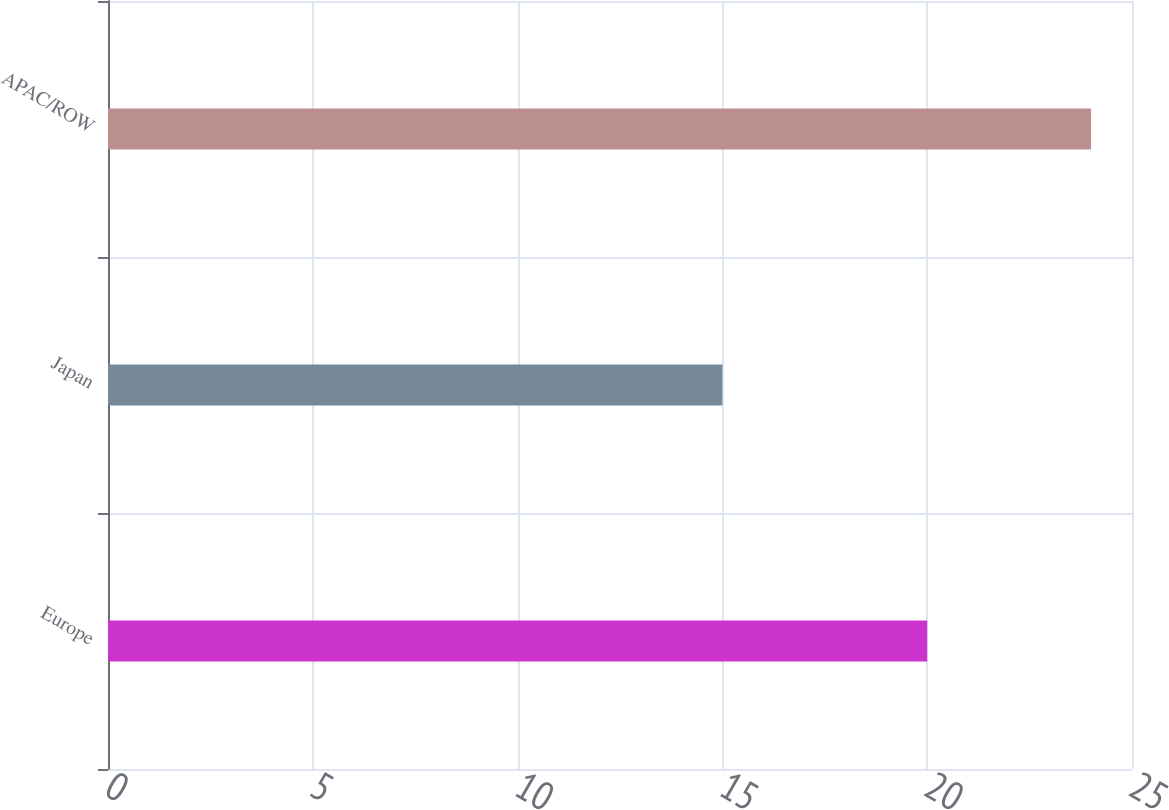Convert chart. <chart><loc_0><loc_0><loc_500><loc_500><bar_chart><fcel>Europe<fcel>Japan<fcel>APAC/ROW<nl><fcel>20<fcel>15<fcel>24<nl></chart> 